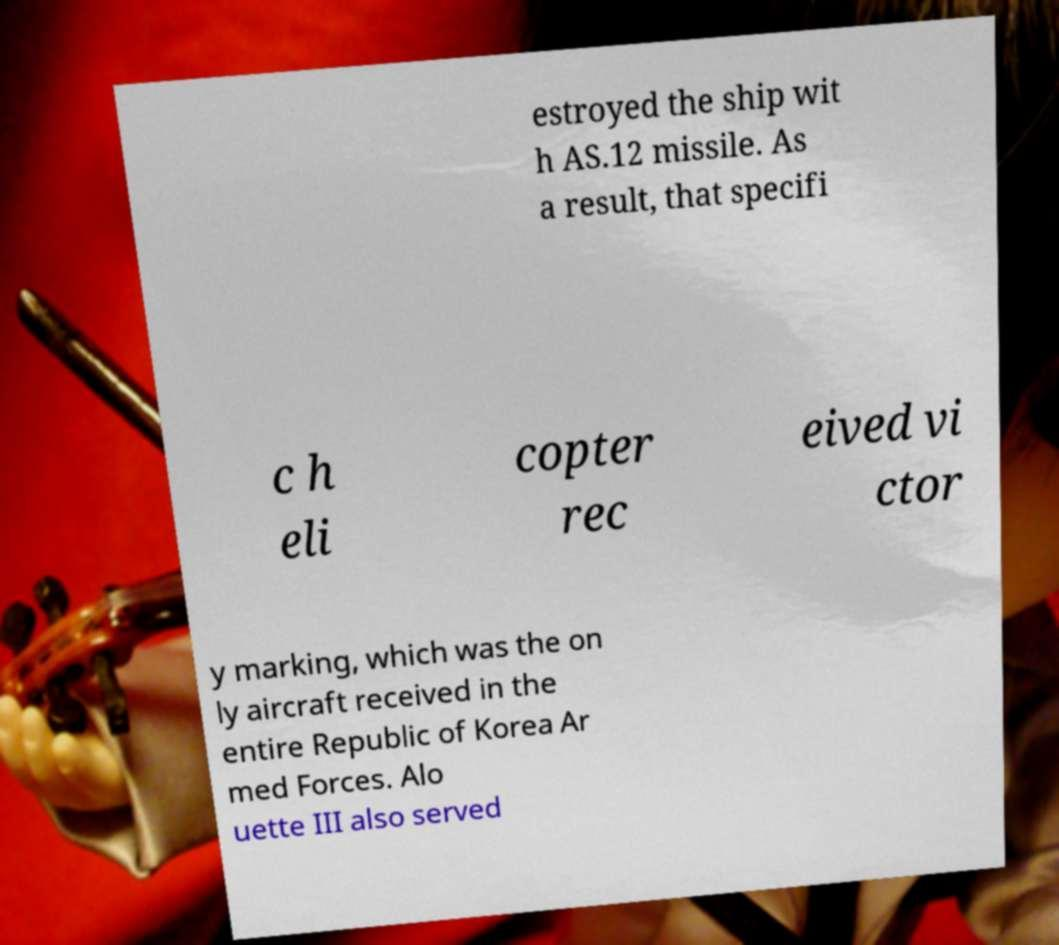Could you extract and type out the text from this image? estroyed the ship wit h AS.12 missile. As a result, that specifi c h eli copter rec eived vi ctor y marking, which was the on ly aircraft received in the entire Republic of Korea Ar med Forces. Alo uette III also served 